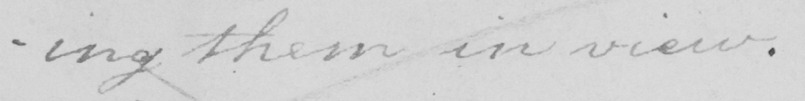Can you read and transcribe this handwriting? -ing them in view . 